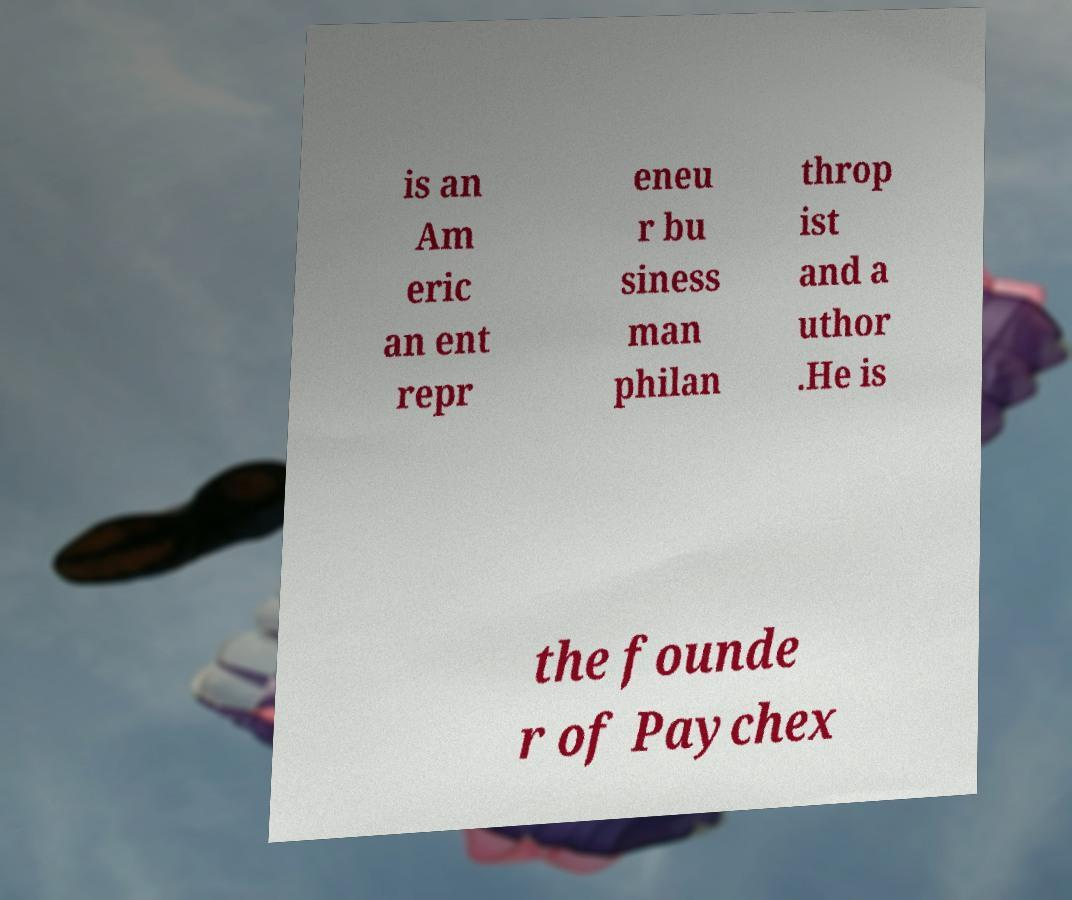There's text embedded in this image that I need extracted. Can you transcribe it verbatim? is an Am eric an ent repr eneu r bu siness man philan throp ist and a uthor .He is the founde r of Paychex 